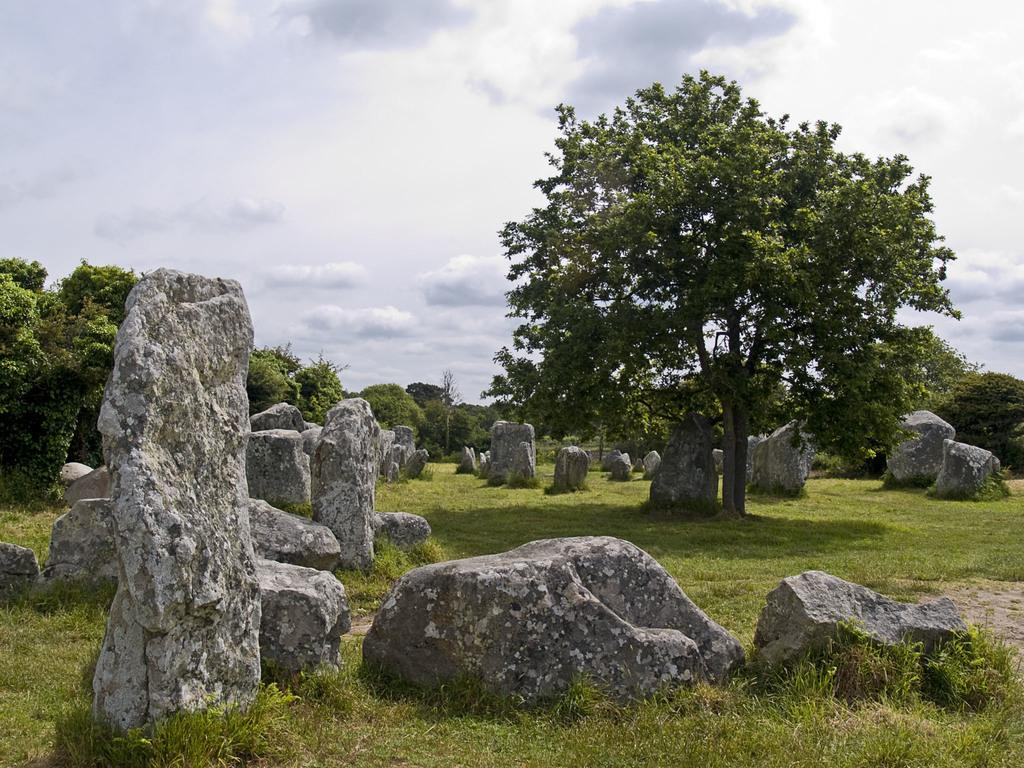What type of natural elements can be seen in the image? There are stones, trees, and grass visible in the image. What is visible at the top of the image? The sky is visible at the top of the image. What can be observed in the sky? Clouds are present in the sky. How many snails can be seen crawling on the stones in the image? There are no snails visible in the image; only stones, trees, grass, and clouds can be observed. 